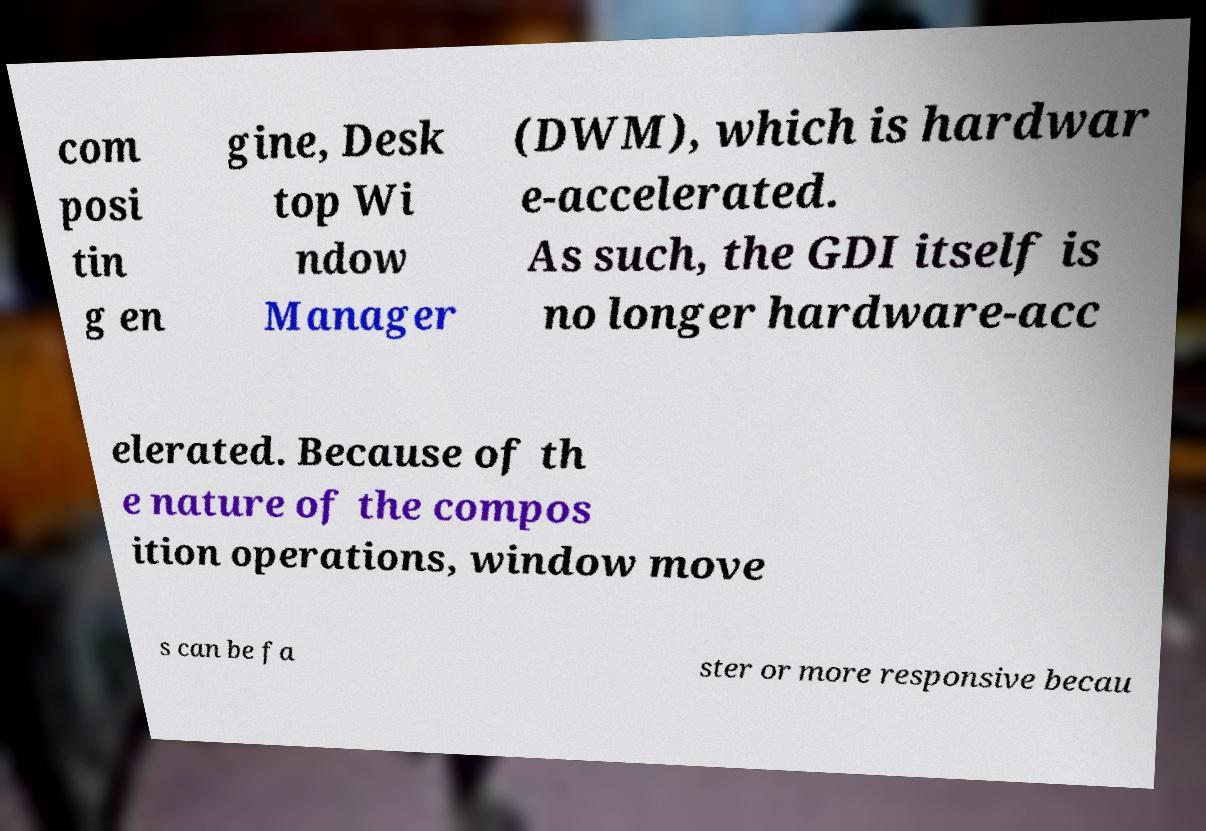Please read and relay the text visible in this image. What does it say? com posi tin g en gine, Desk top Wi ndow Manager (DWM), which is hardwar e-accelerated. As such, the GDI itself is no longer hardware-acc elerated. Because of th e nature of the compos ition operations, window move s can be fa ster or more responsive becau 